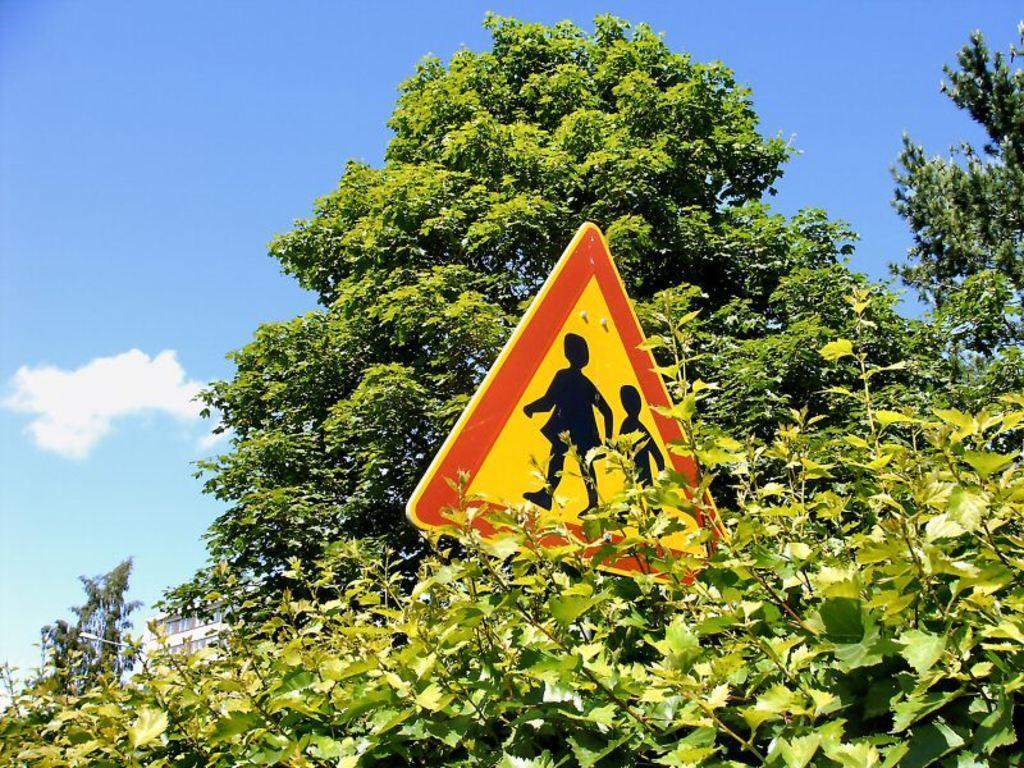Can you describe this image briefly? In this image there are trees. In the center we can see a sign board. In the background there is sky. 